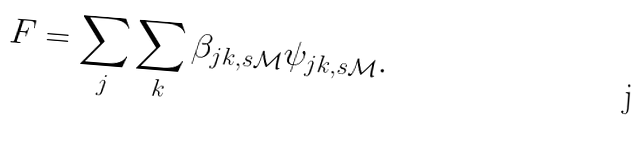<formula> <loc_0><loc_0><loc_500><loc_500>F = \sum _ { j } \sum _ { k } \beta _ { j k , s \mathcal { M } } \psi _ { j k , s \mathcal { M } } .</formula> 